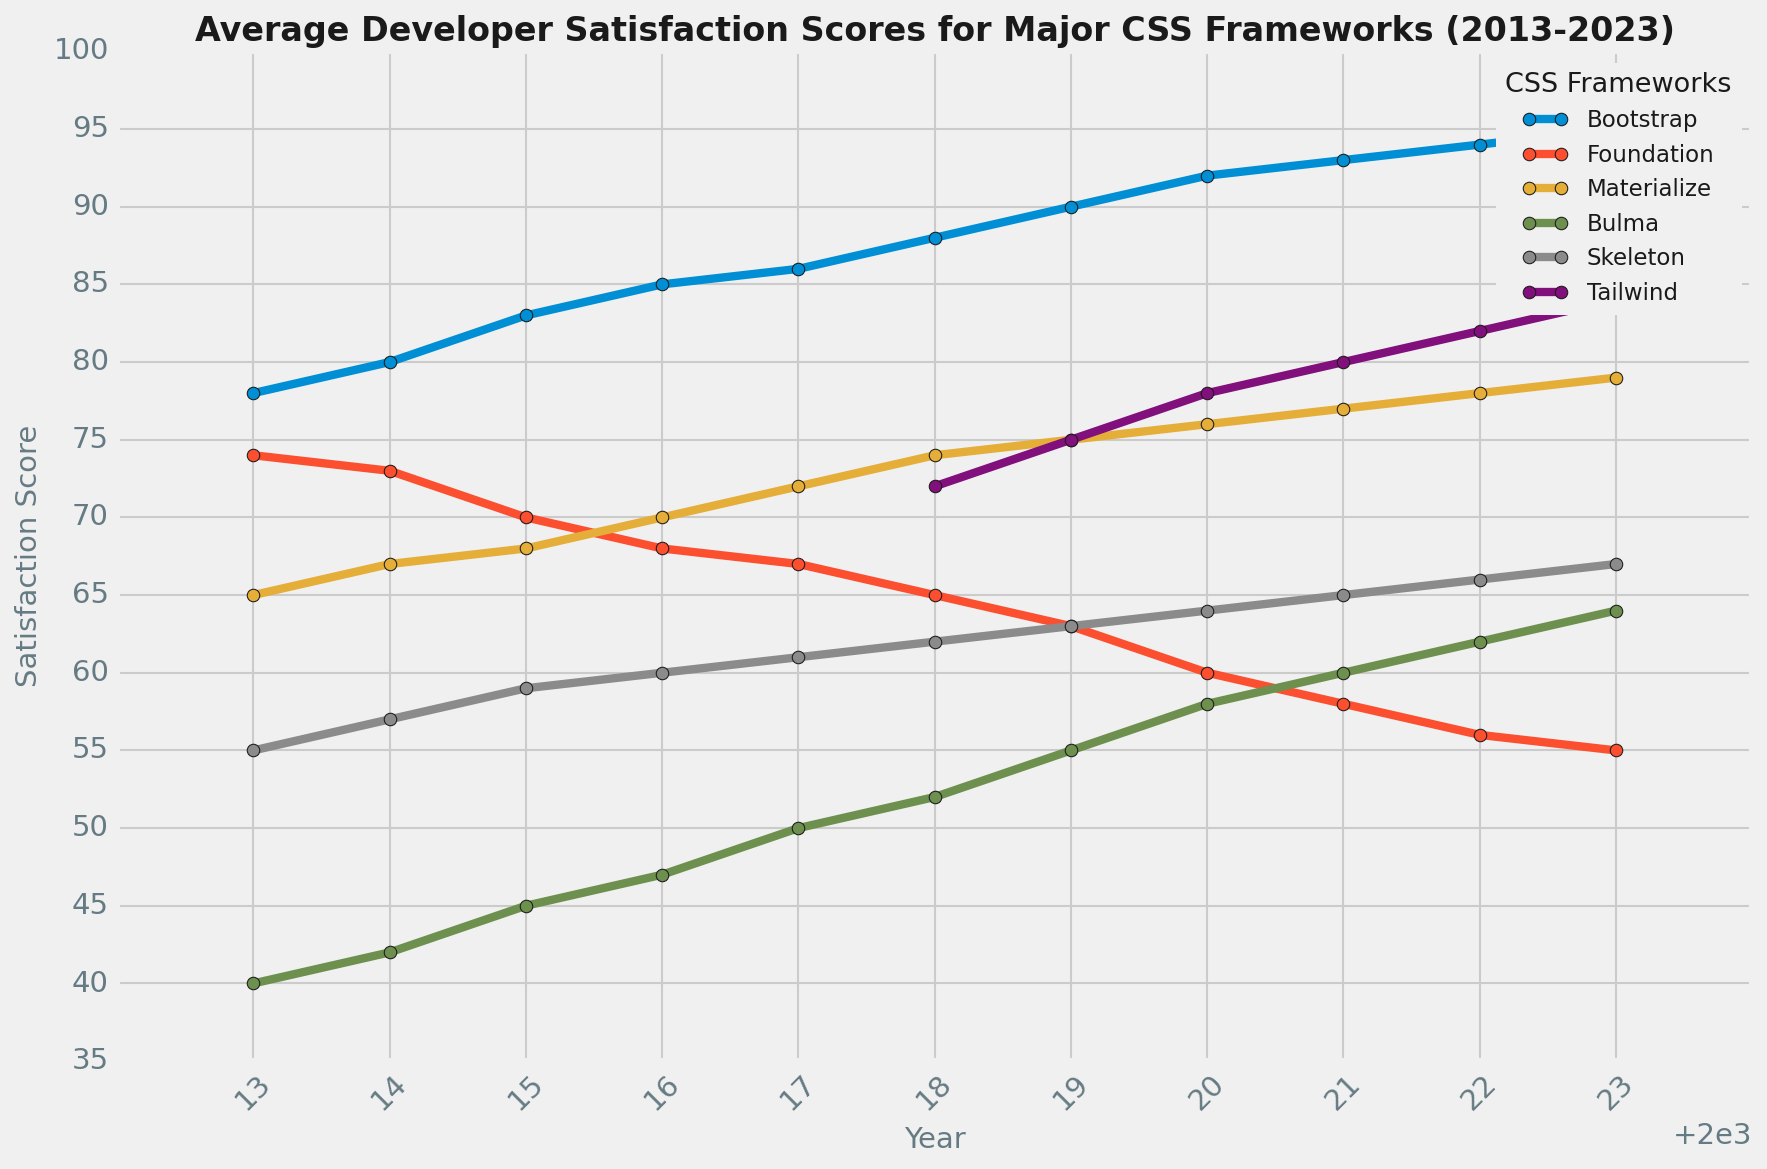What's the average developer satisfaction score for Bootstrap from 2013 to 2023? To calculate the average, sum all the satisfaction scores for Bootstrap from 2013 to 2023: (78 + 80 + 83 + 85 + 86 + 88 + 90 + 92 + 93 + 94 + 95) = 964. Then, divide this sum by the number of years (11): 964 / 11 = 87.64
Answer: 87.64 Which CSS framework had the lowest satisfaction score in 2013? By looking at the satisfaction scores for all frameworks in 2013, we see Bootstrap (78), Foundation (74), Materialize (65), Bulma (40), and Skeleton (55). The lowest score is Bulma with a score of 40.
Answer: Bulma Between which two years did Tailwind see the largest increase in developer satisfaction scores? From 2018 to 2019, satisfaction increased from 72 to 75, a 3-point increase. From 2019 to 2020, increase was from 75 to 78, a 3-point increase. From 2020 to 2021, increase was from 78 to 80, a 2-point increase. From 2021 to 2022, increase was from 80 to 82, a 2-point increase. From 2022 to 2023, increase was from 82 to 84, a 2-point increase. The largest increase is from 2019 to 2020.
Answer: 2019 to 2020 What are the top three frameworks with the highest satisfaction scores in 2023? In 2023, the satisfaction scores for the frameworks are: Bootstrap (95), Foundation (55), Materialize (79), Bulma (64), Skeleton (67), and Tailwind (84). The top three are Bootstrap (95), Tailwind (84), and Materialize (79).
Answer: Bootstrap, Tailwind, Materialize By how much did the satisfaction score for Foundation decrease from 2013 to 2023? Foundation's satisfaction score in 2013 was 74 and in 2023 it was 55. The decrease is 74 - 55 = 19.
Answer: 19 Which framework showed consistent growth in satisfaction scores every year from 2018 to 2023? By examining the yearly changes for each framework from 2018 to 2023, we find: Bulma (52 to 64), Materialize (74 to 79), Skeleton (62 to 67), Tailwind (72 to 84). The only frameworks that showed consistent growth are Bulma, Materialize, Skeleton, and Tailwind.
Answer: Bulma, Materialize, Skeleton, Tailwind Comparing Bootstrap and Foundation in 2023, which has a higher satisfaction score and by how much? In 2023, Bootstrap has a satisfaction score of 95 and Foundation has 55. The difference is 95 - 55 = 40.
Answer: Bootstrap by 40 What trend do you observe for Bootstrap's satisfaction scores from 2013 to 2023? Balloon's satisfaction score steadily increased from 78 in 2013 to 95 in 2023, indicating a positive trend.
Answer: Positive trend Between 2016 and 2018, which framework saw the largest increase in satisfaction score? Between 2016 and 2018, Bulma's score increased from 47 to 52 (+5), Materialize's score increased from 70 to 74 (+4), Tailwind's score went from N/A to 72 (N/A to a positive value but not relevant as it's the first appearance), Bootstrap’s score increased from 85 to 88 (+3), Foundation’s score decreased from 68 to 65 (-3), and Skeleton’s score increased from 60 to 62 (+2). The largest increase was for Bulma with an increase of 5.
Answer: Bulma 